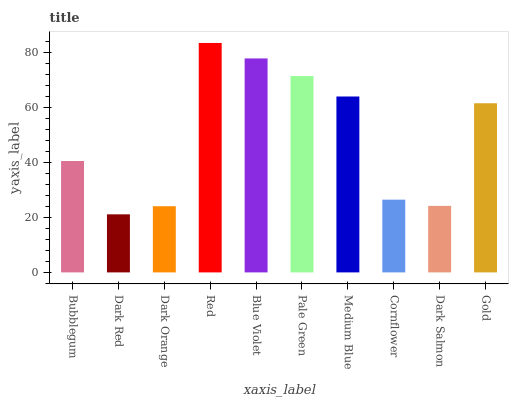Is Dark Red the minimum?
Answer yes or no. Yes. Is Red the maximum?
Answer yes or no. Yes. Is Dark Orange the minimum?
Answer yes or no. No. Is Dark Orange the maximum?
Answer yes or no. No. Is Dark Orange greater than Dark Red?
Answer yes or no. Yes. Is Dark Red less than Dark Orange?
Answer yes or no. Yes. Is Dark Red greater than Dark Orange?
Answer yes or no. No. Is Dark Orange less than Dark Red?
Answer yes or no. No. Is Gold the high median?
Answer yes or no. Yes. Is Bubblegum the low median?
Answer yes or no. Yes. Is Blue Violet the high median?
Answer yes or no. No. Is Dark Salmon the low median?
Answer yes or no. No. 